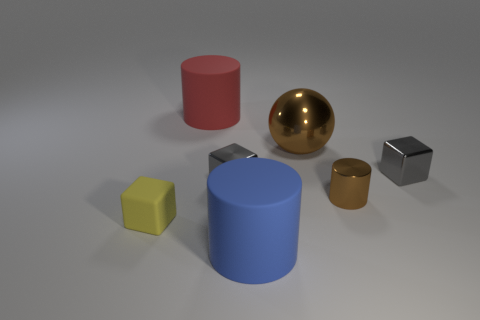There is a matte cylinder behind the tiny gray thing that is right of the brown shiny cylinder; is there a thing in front of it?
Give a very brief answer. Yes. There is a tiny object that is the same shape as the large blue object; what material is it?
Your response must be concise. Metal. How many spheres are tiny purple metallic objects or small yellow rubber things?
Your answer should be very brief. 0. There is a gray shiny cube to the left of the big blue object; is it the same size as the rubber object that is behind the sphere?
Offer a terse response. No. There is a big cylinder that is in front of the large cylinder that is behind the large brown metallic object; what is its material?
Offer a very short reply. Rubber. Is the number of tiny metallic cylinders in front of the big brown metal object less than the number of yellow rubber cubes?
Keep it short and to the point. No. What is the shape of the tiny yellow thing that is the same material as the blue thing?
Your answer should be compact. Cube. How many other objects are the same shape as the red rubber object?
Your response must be concise. 2. How many green objects are either cubes or tiny matte blocks?
Make the answer very short. 0. Do the small brown object and the blue matte object have the same shape?
Offer a very short reply. Yes. 